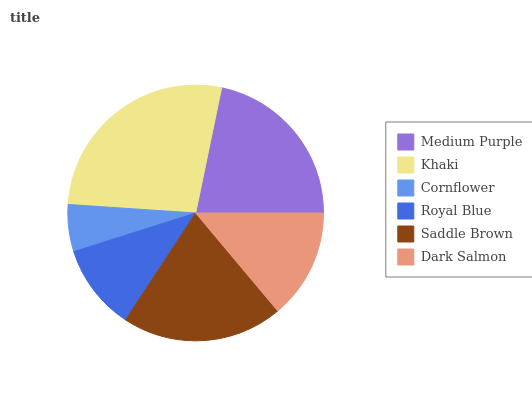Is Cornflower the minimum?
Answer yes or no. Yes. Is Khaki the maximum?
Answer yes or no. Yes. Is Khaki the minimum?
Answer yes or no. No. Is Cornflower the maximum?
Answer yes or no. No. Is Khaki greater than Cornflower?
Answer yes or no. Yes. Is Cornflower less than Khaki?
Answer yes or no. Yes. Is Cornflower greater than Khaki?
Answer yes or no. No. Is Khaki less than Cornflower?
Answer yes or no. No. Is Saddle Brown the high median?
Answer yes or no. Yes. Is Dark Salmon the low median?
Answer yes or no. Yes. Is Khaki the high median?
Answer yes or no. No. Is Medium Purple the low median?
Answer yes or no. No. 